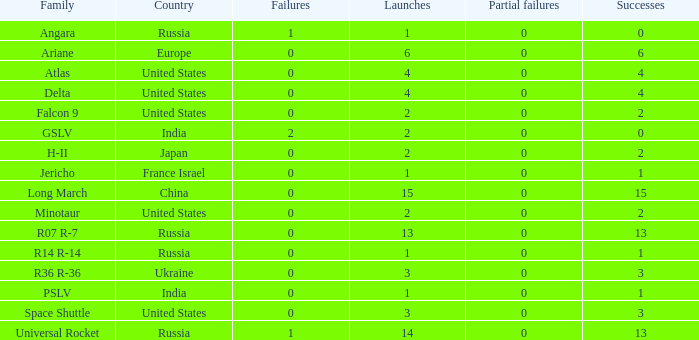What is the number of failure for the country of Russia, and a Family of r14 r-14, and a Partial failures smaller than 0? 0.0. 